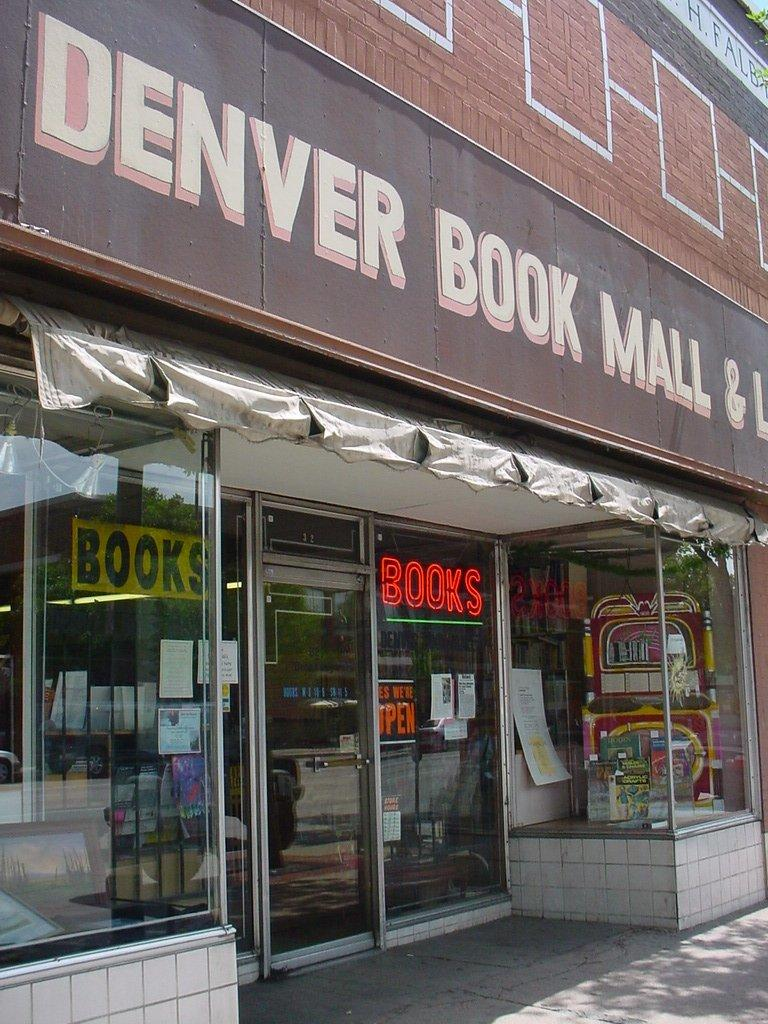<image>
Offer a succinct explanation of the picture presented. The book store in Denver is currently open. 